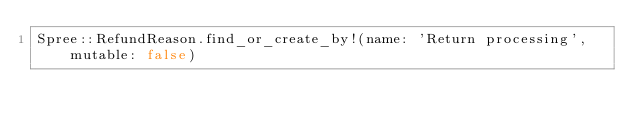Convert code to text. <code><loc_0><loc_0><loc_500><loc_500><_Ruby_>Spree::RefundReason.find_or_create_by!(name: 'Return processing', mutable: false)
</code> 